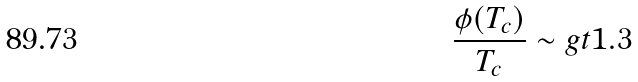<formula> <loc_0><loc_0><loc_500><loc_500>\frac { \phi ( T _ { c } ) } { T _ { c } } \sim g t 1 . 3</formula> 